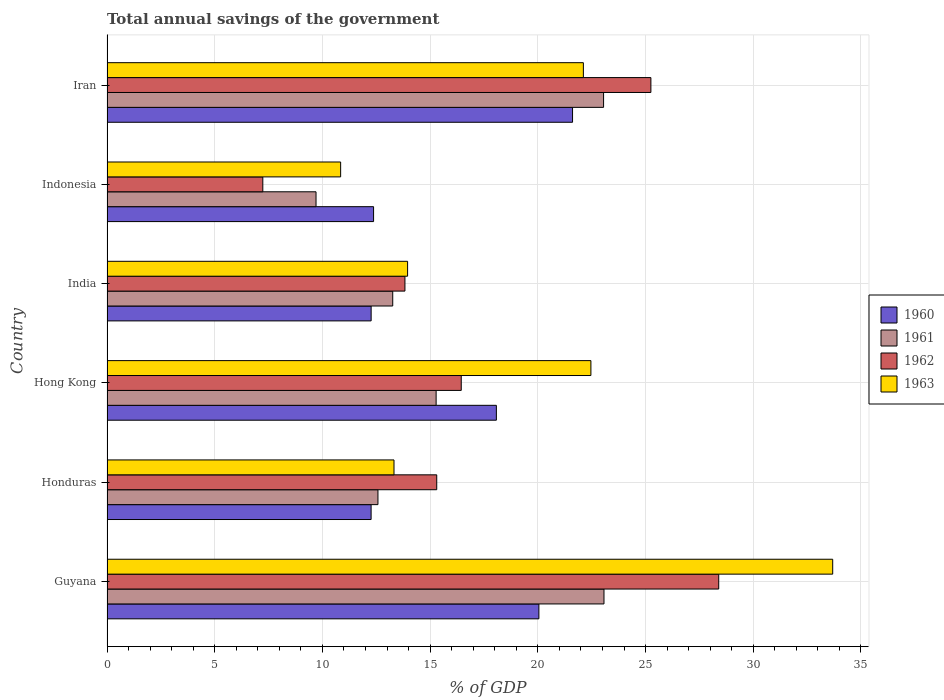How many different coloured bars are there?
Offer a very short reply. 4. How many groups of bars are there?
Your response must be concise. 6. Are the number of bars per tick equal to the number of legend labels?
Offer a very short reply. Yes. How many bars are there on the 1st tick from the top?
Provide a short and direct response. 4. How many bars are there on the 1st tick from the bottom?
Make the answer very short. 4. What is the label of the 6th group of bars from the top?
Provide a succinct answer. Guyana. What is the total annual savings of the government in 1961 in Iran?
Provide a short and direct response. 23.05. Across all countries, what is the maximum total annual savings of the government in 1963?
Provide a succinct answer. 33.69. Across all countries, what is the minimum total annual savings of the government in 1962?
Provide a short and direct response. 7.23. In which country was the total annual savings of the government in 1962 maximum?
Ensure brevity in your answer.  Guyana. In which country was the total annual savings of the government in 1962 minimum?
Provide a succinct answer. Indonesia. What is the total total annual savings of the government in 1962 in the graph?
Make the answer very short. 106.46. What is the difference between the total annual savings of the government in 1960 in Hong Kong and that in Indonesia?
Make the answer very short. 5.7. What is the difference between the total annual savings of the government in 1962 in Honduras and the total annual savings of the government in 1963 in Iran?
Your answer should be compact. -6.81. What is the average total annual savings of the government in 1961 per country?
Ensure brevity in your answer.  16.16. What is the difference between the total annual savings of the government in 1961 and total annual savings of the government in 1963 in Iran?
Ensure brevity in your answer.  0.94. In how many countries, is the total annual savings of the government in 1960 greater than 13 %?
Your response must be concise. 3. What is the ratio of the total annual savings of the government in 1960 in Guyana to that in Hong Kong?
Your answer should be very brief. 1.11. What is the difference between the highest and the second highest total annual savings of the government in 1961?
Keep it short and to the point. 0.02. What is the difference between the highest and the lowest total annual savings of the government in 1962?
Offer a terse response. 21.16. In how many countries, is the total annual savings of the government in 1963 greater than the average total annual savings of the government in 1963 taken over all countries?
Give a very brief answer. 3. Is the sum of the total annual savings of the government in 1963 in Honduras and Indonesia greater than the maximum total annual savings of the government in 1962 across all countries?
Your response must be concise. No. Is it the case that in every country, the sum of the total annual savings of the government in 1960 and total annual savings of the government in 1962 is greater than the sum of total annual savings of the government in 1961 and total annual savings of the government in 1963?
Provide a succinct answer. No. What does the 2nd bar from the top in Guyana represents?
Your answer should be very brief. 1962. What does the 3rd bar from the bottom in Hong Kong represents?
Keep it short and to the point. 1962. Is it the case that in every country, the sum of the total annual savings of the government in 1960 and total annual savings of the government in 1961 is greater than the total annual savings of the government in 1962?
Your answer should be compact. Yes. Are all the bars in the graph horizontal?
Your answer should be compact. Yes. What is the difference between two consecutive major ticks on the X-axis?
Ensure brevity in your answer.  5. Where does the legend appear in the graph?
Your response must be concise. Center right. How are the legend labels stacked?
Your response must be concise. Vertical. What is the title of the graph?
Your response must be concise. Total annual savings of the government. Does "2012" appear as one of the legend labels in the graph?
Make the answer very short. No. What is the label or title of the X-axis?
Give a very brief answer. % of GDP. What is the label or title of the Y-axis?
Your answer should be compact. Country. What is the % of GDP in 1960 in Guyana?
Ensure brevity in your answer.  20.05. What is the % of GDP of 1961 in Guyana?
Make the answer very short. 23.07. What is the % of GDP of 1962 in Guyana?
Make the answer very short. 28.4. What is the % of GDP in 1963 in Guyana?
Provide a short and direct response. 33.69. What is the % of GDP of 1960 in Honduras?
Provide a succinct answer. 12.26. What is the % of GDP in 1961 in Honduras?
Provide a succinct answer. 12.58. What is the % of GDP of 1962 in Honduras?
Offer a terse response. 15.31. What is the % of GDP of 1963 in Honduras?
Keep it short and to the point. 13.32. What is the % of GDP in 1960 in Hong Kong?
Give a very brief answer. 18.07. What is the % of GDP of 1961 in Hong Kong?
Provide a short and direct response. 15.28. What is the % of GDP in 1962 in Hong Kong?
Ensure brevity in your answer.  16.44. What is the % of GDP in 1963 in Hong Kong?
Make the answer very short. 22.46. What is the % of GDP in 1960 in India?
Your answer should be very brief. 12.26. What is the % of GDP in 1961 in India?
Your answer should be very brief. 13.26. What is the % of GDP of 1962 in India?
Your response must be concise. 13.83. What is the % of GDP in 1963 in India?
Offer a terse response. 13.95. What is the % of GDP of 1960 in Indonesia?
Your response must be concise. 12.37. What is the % of GDP of 1961 in Indonesia?
Your answer should be compact. 9.7. What is the % of GDP of 1962 in Indonesia?
Provide a succinct answer. 7.23. What is the % of GDP in 1963 in Indonesia?
Offer a very short reply. 10.85. What is the % of GDP of 1960 in Iran?
Give a very brief answer. 21.61. What is the % of GDP of 1961 in Iran?
Keep it short and to the point. 23.05. What is the % of GDP of 1962 in Iran?
Keep it short and to the point. 25.25. What is the % of GDP of 1963 in Iran?
Give a very brief answer. 22.11. Across all countries, what is the maximum % of GDP of 1960?
Offer a terse response. 21.61. Across all countries, what is the maximum % of GDP of 1961?
Provide a succinct answer. 23.07. Across all countries, what is the maximum % of GDP of 1962?
Make the answer very short. 28.4. Across all countries, what is the maximum % of GDP of 1963?
Your response must be concise. 33.69. Across all countries, what is the minimum % of GDP of 1960?
Provide a short and direct response. 12.26. Across all countries, what is the minimum % of GDP in 1961?
Offer a very short reply. 9.7. Across all countries, what is the minimum % of GDP of 1962?
Provide a succinct answer. 7.23. Across all countries, what is the minimum % of GDP of 1963?
Your answer should be compact. 10.85. What is the total % of GDP in 1960 in the graph?
Your answer should be very brief. 96.63. What is the total % of GDP in 1961 in the graph?
Give a very brief answer. 96.94. What is the total % of GDP in 1962 in the graph?
Provide a succinct answer. 106.46. What is the total % of GDP in 1963 in the graph?
Give a very brief answer. 116.39. What is the difference between the % of GDP in 1960 in Guyana and that in Honduras?
Offer a very short reply. 7.79. What is the difference between the % of GDP of 1961 in Guyana and that in Honduras?
Your answer should be compact. 10.49. What is the difference between the % of GDP in 1962 in Guyana and that in Honduras?
Provide a short and direct response. 13.09. What is the difference between the % of GDP of 1963 in Guyana and that in Honduras?
Provide a succinct answer. 20.36. What is the difference between the % of GDP of 1960 in Guyana and that in Hong Kong?
Ensure brevity in your answer.  1.97. What is the difference between the % of GDP in 1961 in Guyana and that in Hong Kong?
Provide a short and direct response. 7.79. What is the difference between the % of GDP of 1962 in Guyana and that in Hong Kong?
Give a very brief answer. 11.95. What is the difference between the % of GDP in 1963 in Guyana and that in Hong Kong?
Provide a succinct answer. 11.22. What is the difference between the % of GDP in 1960 in Guyana and that in India?
Your answer should be very brief. 7.79. What is the difference between the % of GDP of 1961 in Guyana and that in India?
Your answer should be very brief. 9.81. What is the difference between the % of GDP of 1962 in Guyana and that in India?
Your answer should be compact. 14.57. What is the difference between the % of GDP of 1963 in Guyana and that in India?
Offer a terse response. 19.73. What is the difference between the % of GDP of 1960 in Guyana and that in Indonesia?
Your answer should be very brief. 7.67. What is the difference between the % of GDP of 1961 in Guyana and that in Indonesia?
Offer a very short reply. 13.37. What is the difference between the % of GDP of 1962 in Guyana and that in Indonesia?
Offer a terse response. 21.16. What is the difference between the % of GDP of 1963 in Guyana and that in Indonesia?
Offer a very short reply. 22.84. What is the difference between the % of GDP of 1960 in Guyana and that in Iran?
Offer a very short reply. -1.56. What is the difference between the % of GDP in 1961 in Guyana and that in Iran?
Your answer should be very brief. 0.02. What is the difference between the % of GDP of 1962 in Guyana and that in Iran?
Your response must be concise. 3.15. What is the difference between the % of GDP of 1963 in Guyana and that in Iran?
Make the answer very short. 11.57. What is the difference between the % of GDP of 1960 in Honduras and that in Hong Kong?
Your answer should be compact. -5.82. What is the difference between the % of GDP of 1961 in Honduras and that in Hong Kong?
Give a very brief answer. -2.7. What is the difference between the % of GDP of 1962 in Honduras and that in Hong Kong?
Ensure brevity in your answer.  -1.14. What is the difference between the % of GDP in 1963 in Honduras and that in Hong Kong?
Your answer should be compact. -9.14. What is the difference between the % of GDP in 1960 in Honduras and that in India?
Keep it short and to the point. -0. What is the difference between the % of GDP in 1961 in Honduras and that in India?
Keep it short and to the point. -0.69. What is the difference between the % of GDP in 1962 in Honduras and that in India?
Make the answer very short. 1.48. What is the difference between the % of GDP of 1963 in Honduras and that in India?
Your response must be concise. -0.63. What is the difference between the % of GDP in 1960 in Honduras and that in Indonesia?
Ensure brevity in your answer.  -0.11. What is the difference between the % of GDP in 1961 in Honduras and that in Indonesia?
Your answer should be compact. 2.87. What is the difference between the % of GDP of 1962 in Honduras and that in Indonesia?
Your response must be concise. 8.07. What is the difference between the % of GDP in 1963 in Honduras and that in Indonesia?
Keep it short and to the point. 2.48. What is the difference between the % of GDP in 1960 in Honduras and that in Iran?
Your answer should be very brief. -9.35. What is the difference between the % of GDP of 1961 in Honduras and that in Iran?
Your answer should be very brief. -10.47. What is the difference between the % of GDP in 1962 in Honduras and that in Iran?
Offer a terse response. -9.94. What is the difference between the % of GDP of 1963 in Honduras and that in Iran?
Make the answer very short. -8.79. What is the difference between the % of GDP of 1960 in Hong Kong and that in India?
Ensure brevity in your answer.  5.81. What is the difference between the % of GDP of 1961 in Hong Kong and that in India?
Offer a terse response. 2.01. What is the difference between the % of GDP of 1962 in Hong Kong and that in India?
Your answer should be very brief. 2.61. What is the difference between the % of GDP in 1963 in Hong Kong and that in India?
Ensure brevity in your answer.  8.51. What is the difference between the % of GDP of 1960 in Hong Kong and that in Indonesia?
Give a very brief answer. 5.7. What is the difference between the % of GDP in 1961 in Hong Kong and that in Indonesia?
Provide a succinct answer. 5.58. What is the difference between the % of GDP of 1962 in Hong Kong and that in Indonesia?
Your response must be concise. 9.21. What is the difference between the % of GDP of 1963 in Hong Kong and that in Indonesia?
Offer a terse response. 11.62. What is the difference between the % of GDP of 1960 in Hong Kong and that in Iran?
Offer a very short reply. -3.54. What is the difference between the % of GDP in 1961 in Hong Kong and that in Iran?
Your answer should be very brief. -7.77. What is the difference between the % of GDP in 1962 in Hong Kong and that in Iran?
Give a very brief answer. -8.8. What is the difference between the % of GDP of 1963 in Hong Kong and that in Iran?
Your answer should be very brief. 0.35. What is the difference between the % of GDP in 1960 in India and that in Indonesia?
Ensure brevity in your answer.  -0.11. What is the difference between the % of GDP of 1961 in India and that in Indonesia?
Give a very brief answer. 3.56. What is the difference between the % of GDP of 1962 in India and that in Indonesia?
Provide a short and direct response. 6.6. What is the difference between the % of GDP of 1963 in India and that in Indonesia?
Give a very brief answer. 3.11. What is the difference between the % of GDP of 1960 in India and that in Iran?
Offer a very short reply. -9.35. What is the difference between the % of GDP in 1961 in India and that in Iran?
Keep it short and to the point. -9.79. What is the difference between the % of GDP in 1962 in India and that in Iran?
Make the answer very short. -11.42. What is the difference between the % of GDP in 1963 in India and that in Iran?
Provide a short and direct response. -8.16. What is the difference between the % of GDP of 1960 in Indonesia and that in Iran?
Make the answer very short. -9.24. What is the difference between the % of GDP in 1961 in Indonesia and that in Iran?
Offer a terse response. -13.35. What is the difference between the % of GDP in 1962 in Indonesia and that in Iran?
Make the answer very short. -18.02. What is the difference between the % of GDP of 1963 in Indonesia and that in Iran?
Your response must be concise. -11.27. What is the difference between the % of GDP of 1960 in Guyana and the % of GDP of 1961 in Honduras?
Ensure brevity in your answer.  7.47. What is the difference between the % of GDP of 1960 in Guyana and the % of GDP of 1962 in Honduras?
Make the answer very short. 4.74. What is the difference between the % of GDP in 1960 in Guyana and the % of GDP in 1963 in Honduras?
Offer a very short reply. 6.73. What is the difference between the % of GDP in 1961 in Guyana and the % of GDP in 1962 in Honduras?
Provide a succinct answer. 7.76. What is the difference between the % of GDP in 1961 in Guyana and the % of GDP in 1963 in Honduras?
Offer a terse response. 9.75. What is the difference between the % of GDP of 1962 in Guyana and the % of GDP of 1963 in Honduras?
Provide a short and direct response. 15.07. What is the difference between the % of GDP in 1960 in Guyana and the % of GDP in 1961 in Hong Kong?
Offer a terse response. 4.77. What is the difference between the % of GDP in 1960 in Guyana and the % of GDP in 1962 in Hong Kong?
Make the answer very short. 3.6. What is the difference between the % of GDP of 1960 in Guyana and the % of GDP of 1963 in Hong Kong?
Offer a terse response. -2.42. What is the difference between the % of GDP in 1961 in Guyana and the % of GDP in 1962 in Hong Kong?
Offer a terse response. 6.63. What is the difference between the % of GDP of 1961 in Guyana and the % of GDP of 1963 in Hong Kong?
Give a very brief answer. 0.61. What is the difference between the % of GDP of 1962 in Guyana and the % of GDP of 1963 in Hong Kong?
Make the answer very short. 5.93. What is the difference between the % of GDP of 1960 in Guyana and the % of GDP of 1961 in India?
Provide a succinct answer. 6.78. What is the difference between the % of GDP of 1960 in Guyana and the % of GDP of 1962 in India?
Offer a terse response. 6.22. What is the difference between the % of GDP of 1960 in Guyana and the % of GDP of 1963 in India?
Keep it short and to the point. 6.09. What is the difference between the % of GDP in 1961 in Guyana and the % of GDP in 1962 in India?
Ensure brevity in your answer.  9.24. What is the difference between the % of GDP in 1961 in Guyana and the % of GDP in 1963 in India?
Offer a very short reply. 9.12. What is the difference between the % of GDP of 1962 in Guyana and the % of GDP of 1963 in India?
Offer a terse response. 14.44. What is the difference between the % of GDP of 1960 in Guyana and the % of GDP of 1961 in Indonesia?
Provide a short and direct response. 10.35. What is the difference between the % of GDP of 1960 in Guyana and the % of GDP of 1962 in Indonesia?
Ensure brevity in your answer.  12.82. What is the difference between the % of GDP in 1960 in Guyana and the % of GDP in 1963 in Indonesia?
Offer a terse response. 9.2. What is the difference between the % of GDP in 1961 in Guyana and the % of GDP in 1962 in Indonesia?
Offer a terse response. 15.84. What is the difference between the % of GDP in 1961 in Guyana and the % of GDP in 1963 in Indonesia?
Keep it short and to the point. 12.22. What is the difference between the % of GDP in 1962 in Guyana and the % of GDP in 1963 in Indonesia?
Make the answer very short. 17.55. What is the difference between the % of GDP in 1960 in Guyana and the % of GDP in 1961 in Iran?
Make the answer very short. -3. What is the difference between the % of GDP in 1960 in Guyana and the % of GDP in 1962 in Iran?
Ensure brevity in your answer.  -5.2. What is the difference between the % of GDP in 1960 in Guyana and the % of GDP in 1963 in Iran?
Offer a terse response. -2.07. What is the difference between the % of GDP in 1961 in Guyana and the % of GDP in 1962 in Iran?
Provide a succinct answer. -2.18. What is the difference between the % of GDP of 1961 in Guyana and the % of GDP of 1963 in Iran?
Offer a very short reply. 0.96. What is the difference between the % of GDP in 1962 in Guyana and the % of GDP in 1963 in Iran?
Offer a terse response. 6.28. What is the difference between the % of GDP of 1960 in Honduras and the % of GDP of 1961 in Hong Kong?
Ensure brevity in your answer.  -3.02. What is the difference between the % of GDP of 1960 in Honduras and the % of GDP of 1962 in Hong Kong?
Give a very brief answer. -4.18. What is the difference between the % of GDP in 1960 in Honduras and the % of GDP in 1963 in Hong Kong?
Offer a terse response. -10.2. What is the difference between the % of GDP of 1961 in Honduras and the % of GDP of 1962 in Hong Kong?
Your answer should be very brief. -3.87. What is the difference between the % of GDP in 1961 in Honduras and the % of GDP in 1963 in Hong Kong?
Offer a terse response. -9.89. What is the difference between the % of GDP of 1962 in Honduras and the % of GDP of 1963 in Hong Kong?
Your answer should be compact. -7.16. What is the difference between the % of GDP of 1960 in Honduras and the % of GDP of 1961 in India?
Your answer should be compact. -1. What is the difference between the % of GDP of 1960 in Honduras and the % of GDP of 1962 in India?
Ensure brevity in your answer.  -1.57. What is the difference between the % of GDP in 1960 in Honduras and the % of GDP in 1963 in India?
Provide a succinct answer. -1.69. What is the difference between the % of GDP of 1961 in Honduras and the % of GDP of 1962 in India?
Keep it short and to the point. -1.25. What is the difference between the % of GDP in 1961 in Honduras and the % of GDP in 1963 in India?
Give a very brief answer. -1.38. What is the difference between the % of GDP of 1962 in Honduras and the % of GDP of 1963 in India?
Offer a very short reply. 1.35. What is the difference between the % of GDP in 1960 in Honduras and the % of GDP in 1961 in Indonesia?
Keep it short and to the point. 2.56. What is the difference between the % of GDP in 1960 in Honduras and the % of GDP in 1962 in Indonesia?
Offer a very short reply. 5.03. What is the difference between the % of GDP in 1960 in Honduras and the % of GDP in 1963 in Indonesia?
Provide a short and direct response. 1.41. What is the difference between the % of GDP of 1961 in Honduras and the % of GDP of 1962 in Indonesia?
Provide a short and direct response. 5.34. What is the difference between the % of GDP of 1961 in Honduras and the % of GDP of 1963 in Indonesia?
Your answer should be very brief. 1.73. What is the difference between the % of GDP in 1962 in Honduras and the % of GDP in 1963 in Indonesia?
Your response must be concise. 4.46. What is the difference between the % of GDP in 1960 in Honduras and the % of GDP in 1961 in Iran?
Offer a very short reply. -10.79. What is the difference between the % of GDP in 1960 in Honduras and the % of GDP in 1962 in Iran?
Your answer should be compact. -12.99. What is the difference between the % of GDP of 1960 in Honduras and the % of GDP of 1963 in Iran?
Give a very brief answer. -9.85. What is the difference between the % of GDP in 1961 in Honduras and the % of GDP in 1962 in Iran?
Ensure brevity in your answer.  -12.67. What is the difference between the % of GDP of 1961 in Honduras and the % of GDP of 1963 in Iran?
Your answer should be very brief. -9.54. What is the difference between the % of GDP in 1962 in Honduras and the % of GDP in 1963 in Iran?
Provide a short and direct response. -6.81. What is the difference between the % of GDP in 1960 in Hong Kong and the % of GDP in 1961 in India?
Offer a terse response. 4.81. What is the difference between the % of GDP of 1960 in Hong Kong and the % of GDP of 1962 in India?
Your answer should be compact. 4.24. What is the difference between the % of GDP of 1960 in Hong Kong and the % of GDP of 1963 in India?
Keep it short and to the point. 4.12. What is the difference between the % of GDP in 1961 in Hong Kong and the % of GDP in 1962 in India?
Make the answer very short. 1.45. What is the difference between the % of GDP in 1961 in Hong Kong and the % of GDP in 1963 in India?
Ensure brevity in your answer.  1.32. What is the difference between the % of GDP of 1962 in Hong Kong and the % of GDP of 1963 in India?
Ensure brevity in your answer.  2.49. What is the difference between the % of GDP of 1960 in Hong Kong and the % of GDP of 1961 in Indonesia?
Offer a very short reply. 8.37. What is the difference between the % of GDP of 1960 in Hong Kong and the % of GDP of 1962 in Indonesia?
Offer a very short reply. 10.84. What is the difference between the % of GDP in 1960 in Hong Kong and the % of GDP in 1963 in Indonesia?
Give a very brief answer. 7.23. What is the difference between the % of GDP of 1961 in Hong Kong and the % of GDP of 1962 in Indonesia?
Your answer should be very brief. 8.05. What is the difference between the % of GDP in 1961 in Hong Kong and the % of GDP in 1963 in Indonesia?
Offer a terse response. 4.43. What is the difference between the % of GDP in 1962 in Hong Kong and the % of GDP in 1963 in Indonesia?
Offer a very short reply. 5.6. What is the difference between the % of GDP in 1960 in Hong Kong and the % of GDP in 1961 in Iran?
Offer a very short reply. -4.98. What is the difference between the % of GDP in 1960 in Hong Kong and the % of GDP in 1962 in Iran?
Offer a terse response. -7.17. What is the difference between the % of GDP in 1960 in Hong Kong and the % of GDP in 1963 in Iran?
Your answer should be very brief. -4.04. What is the difference between the % of GDP of 1961 in Hong Kong and the % of GDP of 1962 in Iran?
Give a very brief answer. -9.97. What is the difference between the % of GDP in 1961 in Hong Kong and the % of GDP in 1963 in Iran?
Offer a very short reply. -6.84. What is the difference between the % of GDP of 1962 in Hong Kong and the % of GDP of 1963 in Iran?
Your response must be concise. -5.67. What is the difference between the % of GDP of 1960 in India and the % of GDP of 1961 in Indonesia?
Your answer should be compact. 2.56. What is the difference between the % of GDP of 1960 in India and the % of GDP of 1962 in Indonesia?
Provide a short and direct response. 5.03. What is the difference between the % of GDP of 1960 in India and the % of GDP of 1963 in Indonesia?
Keep it short and to the point. 1.42. What is the difference between the % of GDP of 1961 in India and the % of GDP of 1962 in Indonesia?
Provide a succinct answer. 6.03. What is the difference between the % of GDP of 1961 in India and the % of GDP of 1963 in Indonesia?
Provide a succinct answer. 2.42. What is the difference between the % of GDP of 1962 in India and the % of GDP of 1963 in Indonesia?
Provide a succinct answer. 2.98. What is the difference between the % of GDP in 1960 in India and the % of GDP in 1961 in Iran?
Provide a short and direct response. -10.79. What is the difference between the % of GDP in 1960 in India and the % of GDP in 1962 in Iran?
Ensure brevity in your answer.  -12.99. What is the difference between the % of GDP in 1960 in India and the % of GDP in 1963 in Iran?
Ensure brevity in your answer.  -9.85. What is the difference between the % of GDP of 1961 in India and the % of GDP of 1962 in Iran?
Your answer should be compact. -11.98. What is the difference between the % of GDP in 1961 in India and the % of GDP in 1963 in Iran?
Your answer should be very brief. -8.85. What is the difference between the % of GDP in 1962 in India and the % of GDP in 1963 in Iran?
Give a very brief answer. -8.28. What is the difference between the % of GDP in 1960 in Indonesia and the % of GDP in 1961 in Iran?
Offer a very short reply. -10.68. What is the difference between the % of GDP in 1960 in Indonesia and the % of GDP in 1962 in Iran?
Give a very brief answer. -12.87. What is the difference between the % of GDP of 1960 in Indonesia and the % of GDP of 1963 in Iran?
Offer a very short reply. -9.74. What is the difference between the % of GDP of 1961 in Indonesia and the % of GDP of 1962 in Iran?
Give a very brief answer. -15.54. What is the difference between the % of GDP in 1961 in Indonesia and the % of GDP in 1963 in Iran?
Give a very brief answer. -12.41. What is the difference between the % of GDP of 1962 in Indonesia and the % of GDP of 1963 in Iran?
Your response must be concise. -14.88. What is the average % of GDP in 1960 per country?
Your answer should be compact. 16.1. What is the average % of GDP in 1961 per country?
Provide a succinct answer. 16.16. What is the average % of GDP of 1962 per country?
Your answer should be very brief. 17.74. What is the average % of GDP of 1963 per country?
Ensure brevity in your answer.  19.4. What is the difference between the % of GDP in 1960 and % of GDP in 1961 in Guyana?
Your answer should be very brief. -3.02. What is the difference between the % of GDP in 1960 and % of GDP in 1962 in Guyana?
Your answer should be very brief. -8.35. What is the difference between the % of GDP in 1960 and % of GDP in 1963 in Guyana?
Provide a short and direct response. -13.64. What is the difference between the % of GDP in 1961 and % of GDP in 1962 in Guyana?
Ensure brevity in your answer.  -5.33. What is the difference between the % of GDP of 1961 and % of GDP of 1963 in Guyana?
Your answer should be compact. -10.62. What is the difference between the % of GDP of 1962 and % of GDP of 1963 in Guyana?
Your response must be concise. -5.29. What is the difference between the % of GDP of 1960 and % of GDP of 1961 in Honduras?
Offer a very short reply. -0.32. What is the difference between the % of GDP of 1960 and % of GDP of 1962 in Honduras?
Offer a very short reply. -3.05. What is the difference between the % of GDP in 1960 and % of GDP in 1963 in Honduras?
Your answer should be compact. -1.06. What is the difference between the % of GDP of 1961 and % of GDP of 1962 in Honduras?
Give a very brief answer. -2.73. What is the difference between the % of GDP of 1961 and % of GDP of 1963 in Honduras?
Provide a succinct answer. -0.75. What is the difference between the % of GDP in 1962 and % of GDP in 1963 in Honduras?
Your response must be concise. 1.98. What is the difference between the % of GDP of 1960 and % of GDP of 1961 in Hong Kong?
Your answer should be compact. 2.8. What is the difference between the % of GDP in 1960 and % of GDP in 1962 in Hong Kong?
Your answer should be compact. 1.63. What is the difference between the % of GDP in 1960 and % of GDP in 1963 in Hong Kong?
Ensure brevity in your answer.  -4.39. What is the difference between the % of GDP in 1961 and % of GDP in 1962 in Hong Kong?
Your answer should be very brief. -1.17. What is the difference between the % of GDP in 1961 and % of GDP in 1963 in Hong Kong?
Your response must be concise. -7.19. What is the difference between the % of GDP of 1962 and % of GDP of 1963 in Hong Kong?
Ensure brevity in your answer.  -6.02. What is the difference between the % of GDP in 1960 and % of GDP in 1961 in India?
Offer a terse response. -1. What is the difference between the % of GDP in 1960 and % of GDP in 1962 in India?
Provide a short and direct response. -1.57. What is the difference between the % of GDP of 1960 and % of GDP of 1963 in India?
Your response must be concise. -1.69. What is the difference between the % of GDP in 1961 and % of GDP in 1962 in India?
Keep it short and to the point. -0.57. What is the difference between the % of GDP in 1961 and % of GDP in 1963 in India?
Offer a terse response. -0.69. What is the difference between the % of GDP of 1962 and % of GDP of 1963 in India?
Ensure brevity in your answer.  -0.12. What is the difference between the % of GDP in 1960 and % of GDP in 1961 in Indonesia?
Give a very brief answer. 2.67. What is the difference between the % of GDP in 1960 and % of GDP in 1962 in Indonesia?
Provide a short and direct response. 5.14. What is the difference between the % of GDP of 1960 and % of GDP of 1963 in Indonesia?
Your response must be concise. 1.53. What is the difference between the % of GDP of 1961 and % of GDP of 1962 in Indonesia?
Make the answer very short. 2.47. What is the difference between the % of GDP of 1961 and % of GDP of 1963 in Indonesia?
Your response must be concise. -1.14. What is the difference between the % of GDP of 1962 and % of GDP of 1963 in Indonesia?
Make the answer very short. -3.61. What is the difference between the % of GDP of 1960 and % of GDP of 1961 in Iran?
Give a very brief answer. -1.44. What is the difference between the % of GDP in 1960 and % of GDP in 1962 in Iran?
Offer a very short reply. -3.64. What is the difference between the % of GDP of 1960 and % of GDP of 1963 in Iran?
Provide a succinct answer. -0.5. What is the difference between the % of GDP in 1961 and % of GDP in 1962 in Iran?
Your answer should be very brief. -2.2. What is the difference between the % of GDP in 1961 and % of GDP in 1963 in Iran?
Your answer should be very brief. 0.94. What is the difference between the % of GDP of 1962 and % of GDP of 1963 in Iran?
Give a very brief answer. 3.13. What is the ratio of the % of GDP in 1960 in Guyana to that in Honduras?
Ensure brevity in your answer.  1.64. What is the ratio of the % of GDP of 1961 in Guyana to that in Honduras?
Ensure brevity in your answer.  1.83. What is the ratio of the % of GDP of 1962 in Guyana to that in Honduras?
Provide a succinct answer. 1.86. What is the ratio of the % of GDP of 1963 in Guyana to that in Honduras?
Offer a very short reply. 2.53. What is the ratio of the % of GDP of 1960 in Guyana to that in Hong Kong?
Offer a very short reply. 1.11. What is the ratio of the % of GDP in 1961 in Guyana to that in Hong Kong?
Offer a very short reply. 1.51. What is the ratio of the % of GDP in 1962 in Guyana to that in Hong Kong?
Make the answer very short. 1.73. What is the ratio of the % of GDP in 1963 in Guyana to that in Hong Kong?
Make the answer very short. 1.5. What is the ratio of the % of GDP in 1960 in Guyana to that in India?
Ensure brevity in your answer.  1.64. What is the ratio of the % of GDP of 1961 in Guyana to that in India?
Make the answer very short. 1.74. What is the ratio of the % of GDP of 1962 in Guyana to that in India?
Provide a succinct answer. 2.05. What is the ratio of the % of GDP of 1963 in Guyana to that in India?
Offer a terse response. 2.41. What is the ratio of the % of GDP of 1960 in Guyana to that in Indonesia?
Offer a very short reply. 1.62. What is the ratio of the % of GDP of 1961 in Guyana to that in Indonesia?
Offer a terse response. 2.38. What is the ratio of the % of GDP of 1962 in Guyana to that in Indonesia?
Your answer should be compact. 3.93. What is the ratio of the % of GDP in 1963 in Guyana to that in Indonesia?
Keep it short and to the point. 3.11. What is the ratio of the % of GDP of 1960 in Guyana to that in Iran?
Provide a succinct answer. 0.93. What is the ratio of the % of GDP of 1962 in Guyana to that in Iran?
Offer a very short reply. 1.12. What is the ratio of the % of GDP of 1963 in Guyana to that in Iran?
Ensure brevity in your answer.  1.52. What is the ratio of the % of GDP in 1960 in Honduras to that in Hong Kong?
Offer a terse response. 0.68. What is the ratio of the % of GDP in 1961 in Honduras to that in Hong Kong?
Your answer should be very brief. 0.82. What is the ratio of the % of GDP in 1962 in Honduras to that in Hong Kong?
Your answer should be compact. 0.93. What is the ratio of the % of GDP of 1963 in Honduras to that in Hong Kong?
Offer a terse response. 0.59. What is the ratio of the % of GDP of 1960 in Honduras to that in India?
Keep it short and to the point. 1. What is the ratio of the % of GDP in 1961 in Honduras to that in India?
Your response must be concise. 0.95. What is the ratio of the % of GDP in 1962 in Honduras to that in India?
Offer a very short reply. 1.11. What is the ratio of the % of GDP of 1963 in Honduras to that in India?
Make the answer very short. 0.95. What is the ratio of the % of GDP of 1961 in Honduras to that in Indonesia?
Ensure brevity in your answer.  1.3. What is the ratio of the % of GDP of 1962 in Honduras to that in Indonesia?
Offer a very short reply. 2.12. What is the ratio of the % of GDP of 1963 in Honduras to that in Indonesia?
Your response must be concise. 1.23. What is the ratio of the % of GDP of 1960 in Honduras to that in Iran?
Make the answer very short. 0.57. What is the ratio of the % of GDP of 1961 in Honduras to that in Iran?
Provide a succinct answer. 0.55. What is the ratio of the % of GDP in 1962 in Honduras to that in Iran?
Offer a terse response. 0.61. What is the ratio of the % of GDP in 1963 in Honduras to that in Iran?
Your answer should be very brief. 0.6. What is the ratio of the % of GDP of 1960 in Hong Kong to that in India?
Keep it short and to the point. 1.47. What is the ratio of the % of GDP in 1961 in Hong Kong to that in India?
Offer a very short reply. 1.15. What is the ratio of the % of GDP in 1962 in Hong Kong to that in India?
Your answer should be compact. 1.19. What is the ratio of the % of GDP in 1963 in Hong Kong to that in India?
Your answer should be very brief. 1.61. What is the ratio of the % of GDP in 1960 in Hong Kong to that in Indonesia?
Offer a terse response. 1.46. What is the ratio of the % of GDP in 1961 in Hong Kong to that in Indonesia?
Provide a short and direct response. 1.57. What is the ratio of the % of GDP in 1962 in Hong Kong to that in Indonesia?
Ensure brevity in your answer.  2.27. What is the ratio of the % of GDP in 1963 in Hong Kong to that in Indonesia?
Make the answer very short. 2.07. What is the ratio of the % of GDP in 1960 in Hong Kong to that in Iran?
Your response must be concise. 0.84. What is the ratio of the % of GDP in 1961 in Hong Kong to that in Iran?
Ensure brevity in your answer.  0.66. What is the ratio of the % of GDP in 1962 in Hong Kong to that in Iran?
Give a very brief answer. 0.65. What is the ratio of the % of GDP in 1963 in Hong Kong to that in Iran?
Ensure brevity in your answer.  1.02. What is the ratio of the % of GDP in 1960 in India to that in Indonesia?
Make the answer very short. 0.99. What is the ratio of the % of GDP of 1961 in India to that in Indonesia?
Provide a short and direct response. 1.37. What is the ratio of the % of GDP of 1962 in India to that in Indonesia?
Ensure brevity in your answer.  1.91. What is the ratio of the % of GDP of 1963 in India to that in Indonesia?
Offer a very short reply. 1.29. What is the ratio of the % of GDP in 1960 in India to that in Iran?
Keep it short and to the point. 0.57. What is the ratio of the % of GDP in 1961 in India to that in Iran?
Your answer should be compact. 0.58. What is the ratio of the % of GDP in 1962 in India to that in Iran?
Your response must be concise. 0.55. What is the ratio of the % of GDP in 1963 in India to that in Iran?
Your answer should be very brief. 0.63. What is the ratio of the % of GDP of 1960 in Indonesia to that in Iran?
Give a very brief answer. 0.57. What is the ratio of the % of GDP of 1961 in Indonesia to that in Iran?
Your answer should be very brief. 0.42. What is the ratio of the % of GDP in 1962 in Indonesia to that in Iran?
Offer a terse response. 0.29. What is the ratio of the % of GDP of 1963 in Indonesia to that in Iran?
Keep it short and to the point. 0.49. What is the difference between the highest and the second highest % of GDP of 1960?
Your answer should be very brief. 1.56. What is the difference between the highest and the second highest % of GDP of 1961?
Provide a succinct answer. 0.02. What is the difference between the highest and the second highest % of GDP in 1962?
Offer a terse response. 3.15. What is the difference between the highest and the second highest % of GDP in 1963?
Your answer should be very brief. 11.22. What is the difference between the highest and the lowest % of GDP in 1960?
Ensure brevity in your answer.  9.35. What is the difference between the highest and the lowest % of GDP in 1961?
Offer a terse response. 13.37. What is the difference between the highest and the lowest % of GDP in 1962?
Provide a succinct answer. 21.16. What is the difference between the highest and the lowest % of GDP of 1963?
Keep it short and to the point. 22.84. 